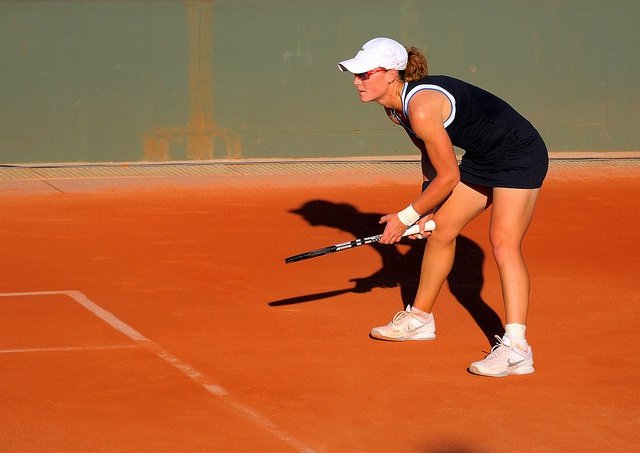Describe the objects in this image and their specific colors. I can see people in gray, black, salmon, red, and white tones and tennis racket in gray, black, ivory, red, and maroon tones in this image. 